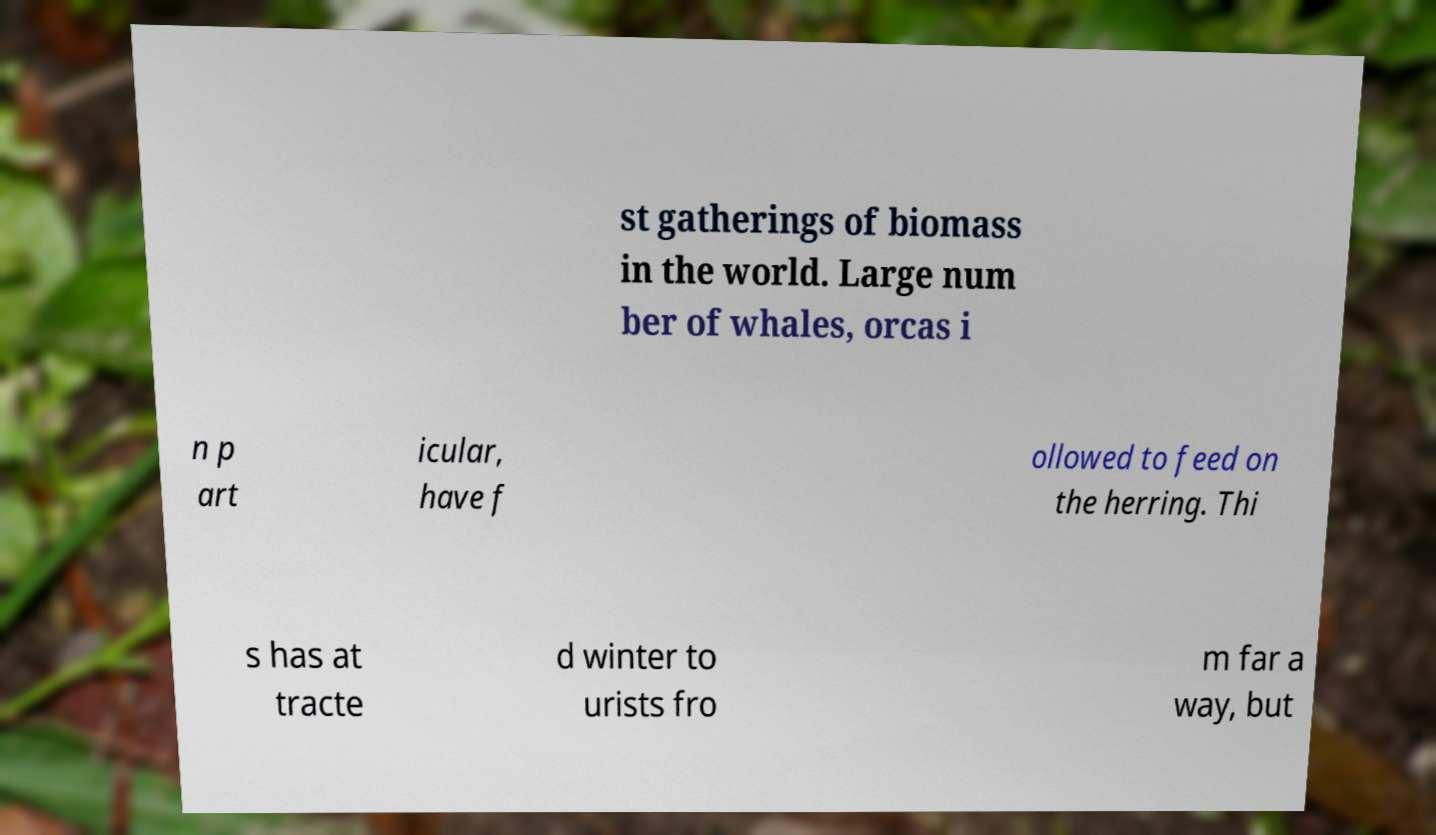Can you accurately transcribe the text from the provided image for me? st gatherings of biomass in the world. Large num ber of whales, orcas i n p art icular, have f ollowed to feed on the herring. Thi s has at tracte d winter to urists fro m far a way, but 